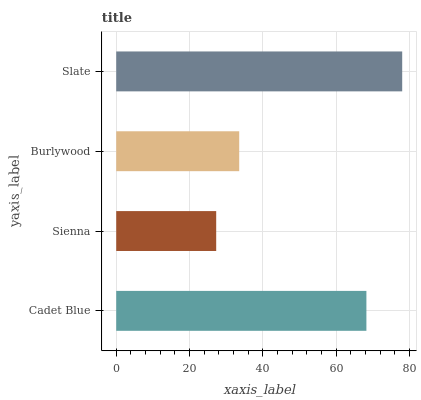Is Sienna the minimum?
Answer yes or no. Yes. Is Slate the maximum?
Answer yes or no. Yes. Is Burlywood the minimum?
Answer yes or no. No. Is Burlywood the maximum?
Answer yes or no. No. Is Burlywood greater than Sienna?
Answer yes or no. Yes. Is Sienna less than Burlywood?
Answer yes or no. Yes. Is Sienna greater than Burlywood?
Answer yes or no. No. Is Burlywood less than Sienna?
Answer yes or no. No. Is Cadet Blue the high median?
Answer yes or no. Yes. Is Burlywood the low median?
Answer yes or no. Yes. Is Slate the high median?
Answer yes or no. No. Is Cadet Blue the low median?
Answer yes or no. No. 